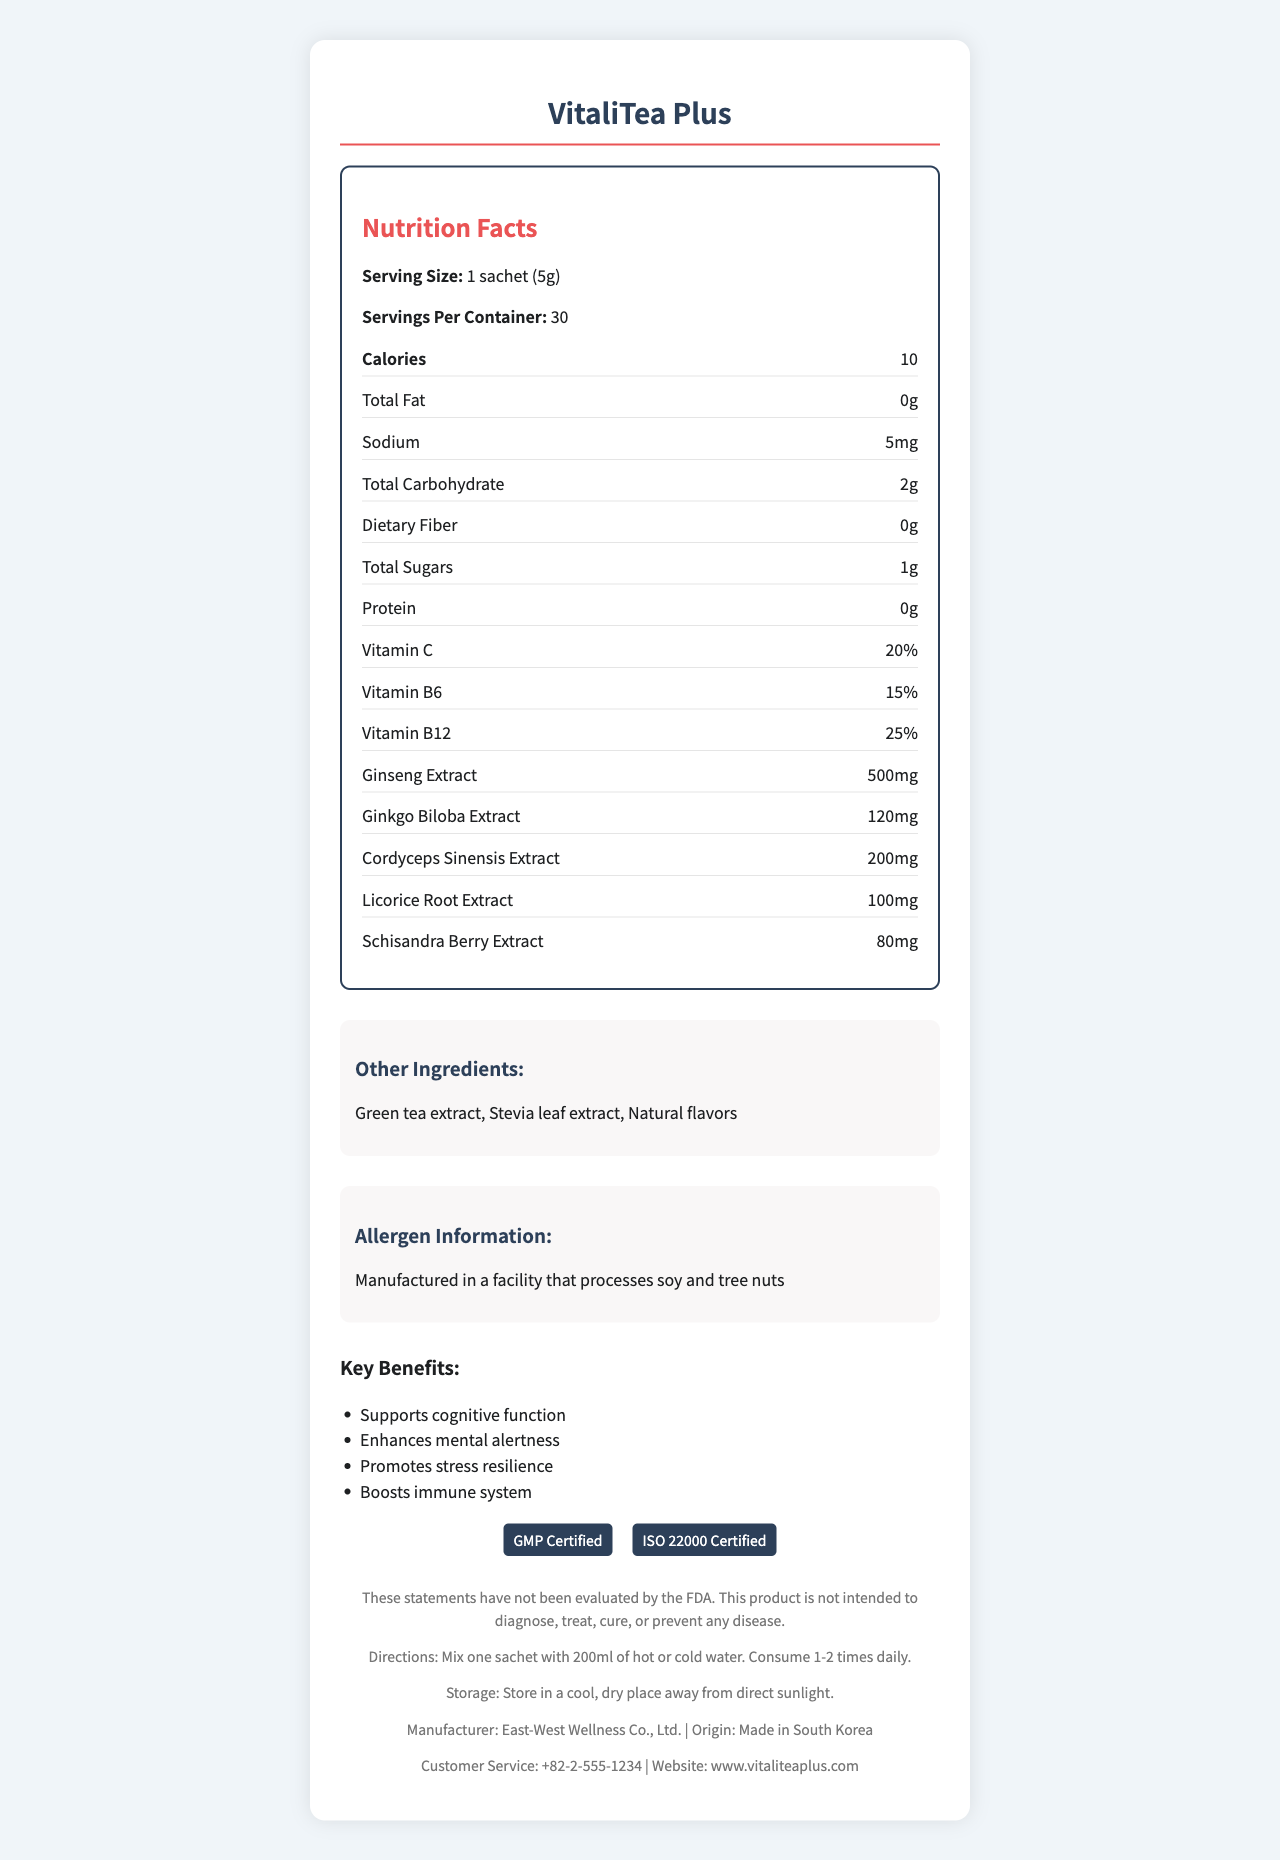what is the serving size of VitaliTea Plus? The serving size is clearly indicated as "1 sachet (5g)" on the document.
Answer: 1 sachet (5g) how many calories are in one serving of VitaliTea Plus? The document lists the calorie count as "10" in the nutrition facts section.
Answer: 10 does VitaliTea Plus contain any protein? The nutrition facts section shows protein as "0g," indicating there is no protein in one serving.
Answer: No describe the allergen information for VitaliTea Plus. The allergen information section mentions the supplement is "Manufactured in a facility that processes soy and tree nuts."
Answer: Manufactured in a facility that processes soy and tree nuts how many servings are there per container of VitaliTea Plus? The servings per container is listed as "30" in the nutrition facts section.
Answer: 30 is VitaliTea Plus recommended for children? The document does not provide any specific information regarding the use of this product by children.
Answer: Cannot be determined what is the main purpose of VitaliTea Plus? The document states the target audience is "Business professionals seeking mental clarity and energy boost," and lists benefits like "Supports cognitive function" and "Enhances mental alertness."
Answer: Boosts mental clarity and energy for business professionals what is the sodium content in one serving of VitaliTea Plus? The sodium content is listed as "5mg" in the nutrition facts section.
Answer: 5mg which of the following ingredients are included in VitaliTea Plus? A. Ginseng Extract B. Stevia leaf extract C. Both A and B D. None of the above Both "Ginseng Extract" and "Stevia leaf extract" are listed among the ingredients.
Answer: C how much ginkgo biloba extract is in each serving of VitaliTea Plus? The document specifies that each serving contains "120mg" of ginkgo biloba extract.
Answer: 120mg does the document state if VitaliTea Plus is FDA approved? The disclaimer section states, "These statements have not been evaluated by the FDA."
Answer: No what is the shelf life of VitaliTea Plus? The document provides the shelf life as "24 months from date of manufacture."
Answer: 24 months from date of manufacture who manufactures VitaliTea Plus? The manufacturer is listed as "East-West Wellness Co., Ltd." in the footer section.
Answer: East-West Wellness Co., Ltd. which vitamins are included in VitaliTea Plus? The nutrition facts section lists Vitamin C, Vitamin B6, and Vitamin B12 among the contents.
Answer: Vitamin C, Vitamin B6, Vitamin B12 describe how to consume VitaliTea Plus The directions section explains how to prepare and consume the supplement.
Answer: Mix one sachet with 200ml of hot or cold water. Consume 1-2 times daily. identify a possible benefit of consuming VitaliTea Plus One of the key benefits listed is "Enhances mental alertness."
Answer: Enhances mental alertness where is VitaliTea Plus manufactured? The footer section indicates that the product is "Made in South Korea."
Answer: Made in South Korea what certifications does VitaliTea Plus have? The certifications section lists "GMP Certified" and "ISO 22000 Certified."
Answer: GMP Certified, ISO 22000 Certified how should VitaliTea Plus be stored? The storage instructions are "Store in a cool, dry place away from direct sunlight."
Answer: Store in a cool, dry place away from direct sunlight. summarize the main information provided in the VitaliTea Plus document The document provides comprehensive details about the supplement, including nutritional facts, ingredients, benefits, usage directions, storage instructions, certifications, and more.
Answer: VitaliTea Plus is an herbal supplement designed for business professionals to enhance mental clarity and energy. It contains ingredients like ginseng extract and ginkgo biloba extract, with vitamins C, B6, and B12. Each serving provides 10 calories, 2g of carbohydrates, and minimal sodium. The product is GMP and ISO 22000 certified, made in South Korea, and stored in a cool, dry place. The document lists directions for use, allergen information, and key benefits of the supplement. 